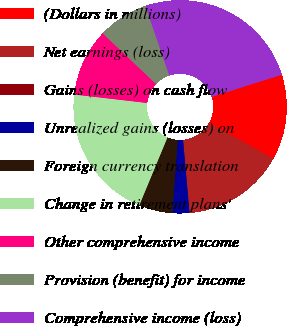Convert chart to OTSL. <chart><loc_0><loc_0><loc_500><loc_500><pie_chart><fcel>(Dollars in millions)<fcel>Net earnings (loss)<fcel>Gains (losses) on cash flow<fcel>Unrealized gains (losses) on<fcel>Foreign currency translation<fcel>Change in retirement plans'<fcel>Other comprehensive income<fcel>Provision (benefit) for income<fcel>Comprehensive income (loss)<nl><fcel>12.96%<fcel>15.5%<fcel>0.02%<fcel>2.56%<fcel>5.1%<fcel>20.58%<fcel>10.24%<fcel>7.64%<fcel>25.41%<nl></chart> 